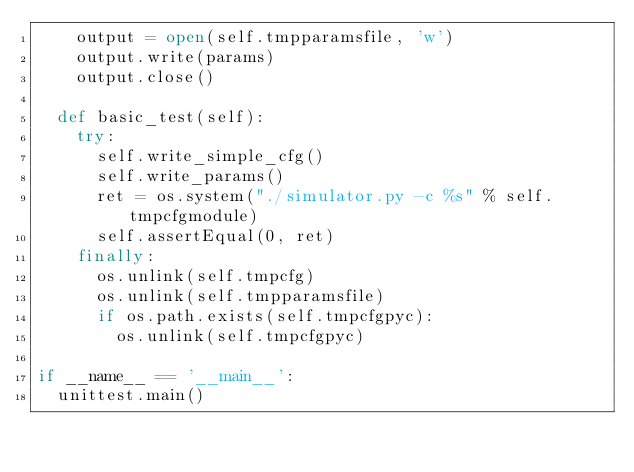Convert code to text. <code><loc_0><loc_0><loc_500><loc_500><_Python_>    output = open(self.tmpparamsfile, 'w')
    output.write(params)
    output.close()

  def basic_test(self):
    try:
      self.write_simple_cfg()
      self.write_params()
      ret = os.system("./simulator.py -c %s" % self.tmpcfgmodule)
      self.assertEqual(0, ret)
    finally:
      os.unlink(self.tmpcfg)
      os.unlink(self.tmpparamsfile)
      if os.path.exists(self.tmpcfgpyc):
        os.unlink(self.tmpcfgpyc)

if __name__ == '__main__':
  unittest.main()
</code> 